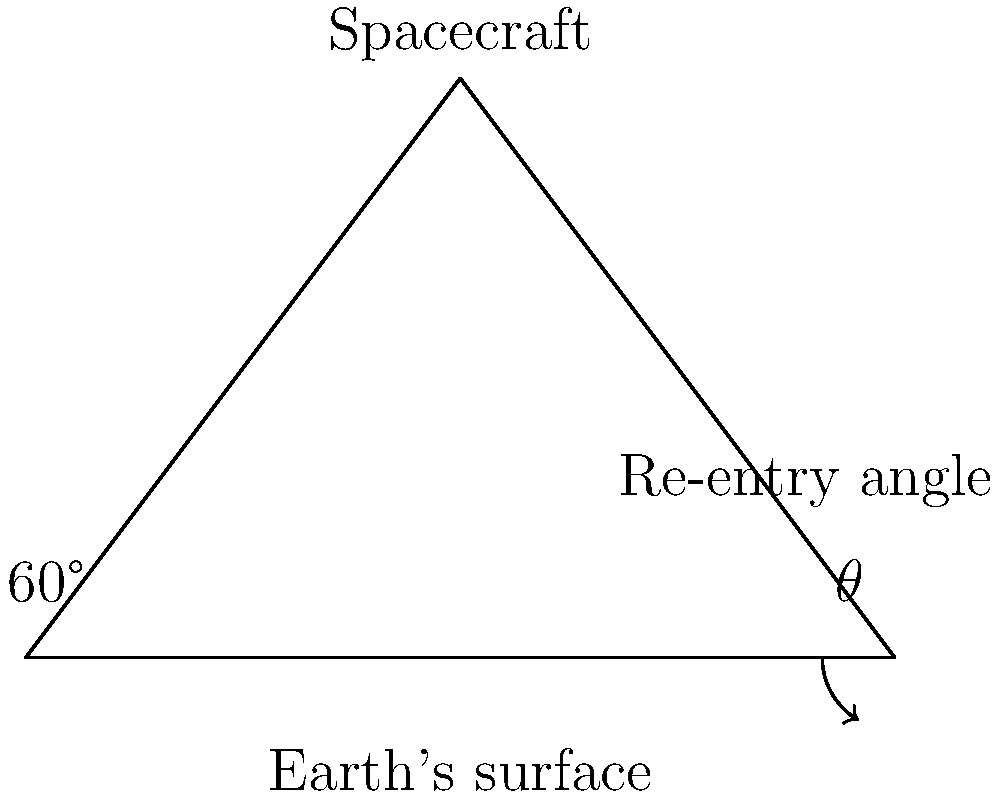During a spacecraft's re-entry, the trajectory forms a triangle with the Earth's surface, as shown in the diagram. If the angle between the spacecraft's path and the Earth's surface is 60°, what is the value of angle $\theta$ at the base of the triangle? Let's approach this step-by-step:

1) In a triangle, the sum of all angles is always 180°.

2) We are given that one angle of the triangle is 60°.

3) The angle at the vertex where the spacecraft is located is 90°. This is because the spacecraft's trajectory is perpendicular to the radius of the Earth at the point of re-entry.

4) Let's call the unknown angle $\theta$.

5) We can set up an equation based on the fact that the sum of angles in a triangle is 180°:

   $$60° + 90° + \theta = 180°$$

6) Simplifying:

   $$150° + \theta = 180°$$

7) Subtracting 150° from both sides:

   $$\theta = 180° - 150° = 30°$$

Therefore, the value of angle $\theta$ is 30°.
Answer: 30° 